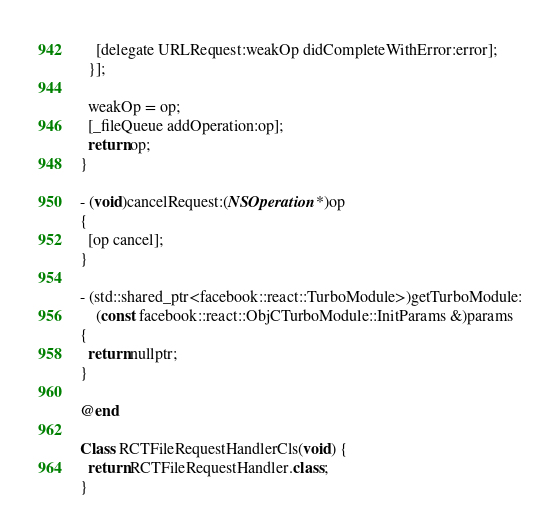<code> <loc_0><loc_0><loc_500><loc_500><_ObjectiveC_>    [delegate URLRequest:weakOp didCompleteWithError:error];
  }];

  weakOp = op;
  [_fileQueue addOperation:op];
  return op;
}

- (void)cancelRequest:(NSOperation *)op
{
  [op cancel];
}

- (std::shared_ptr<facebook::react::TurboModule>)getTurboModule:
    (const facebook::react::ObjCTurboModule::InitParams &)params
{
  return nullptr;
}

@end

Class RCTFileRequestHandlerCls(void) {
  return RCTFileRequestHandler.class;
}
</code> 